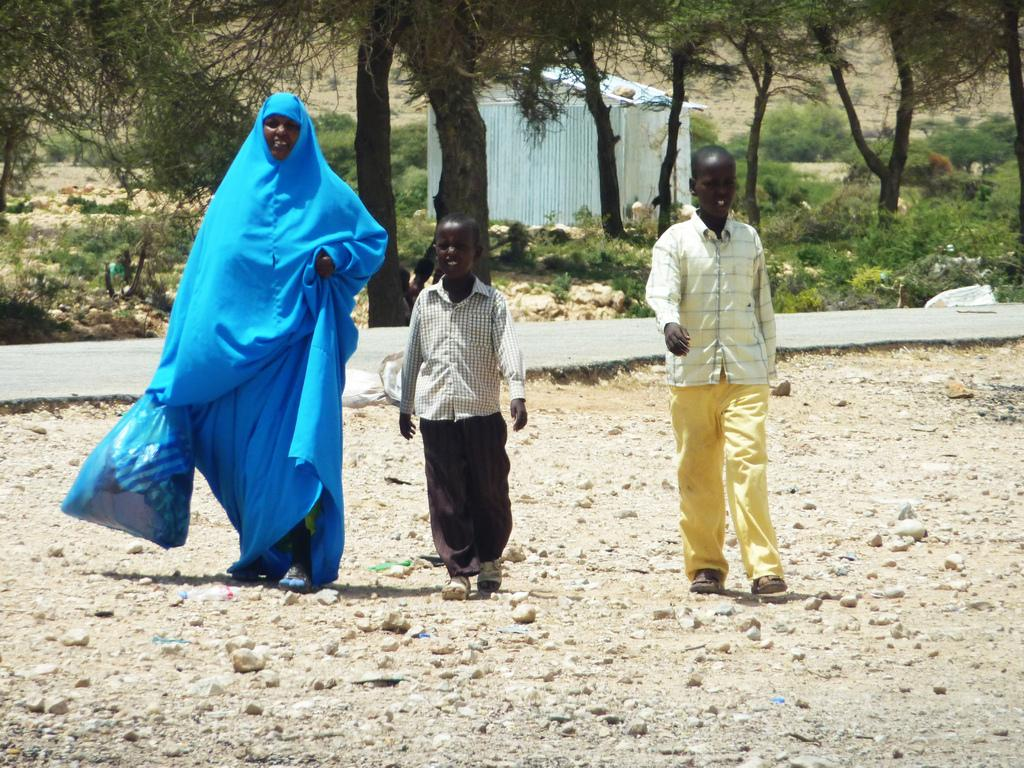How many people are present in the image? There are three people on the ground in the image. What is the woman holding in the image? The woman is holding a plastic bag. What can be seen in the background of the image? There is a road, a shed, trees, and plants visible in the background of the image. What type of religion is being practiced by the people in the image? There is no indication of any religious practice in the image; it simply shows three people on the ground and a woman holding a plastic bag. 